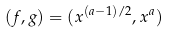Convert formula to latex. <formula><loc_0><loc_0><loc_500><loc_500>( f , g ) = ( x ^ { ( a - 1 ) / 2 } , x ^ { a } )</formula> 